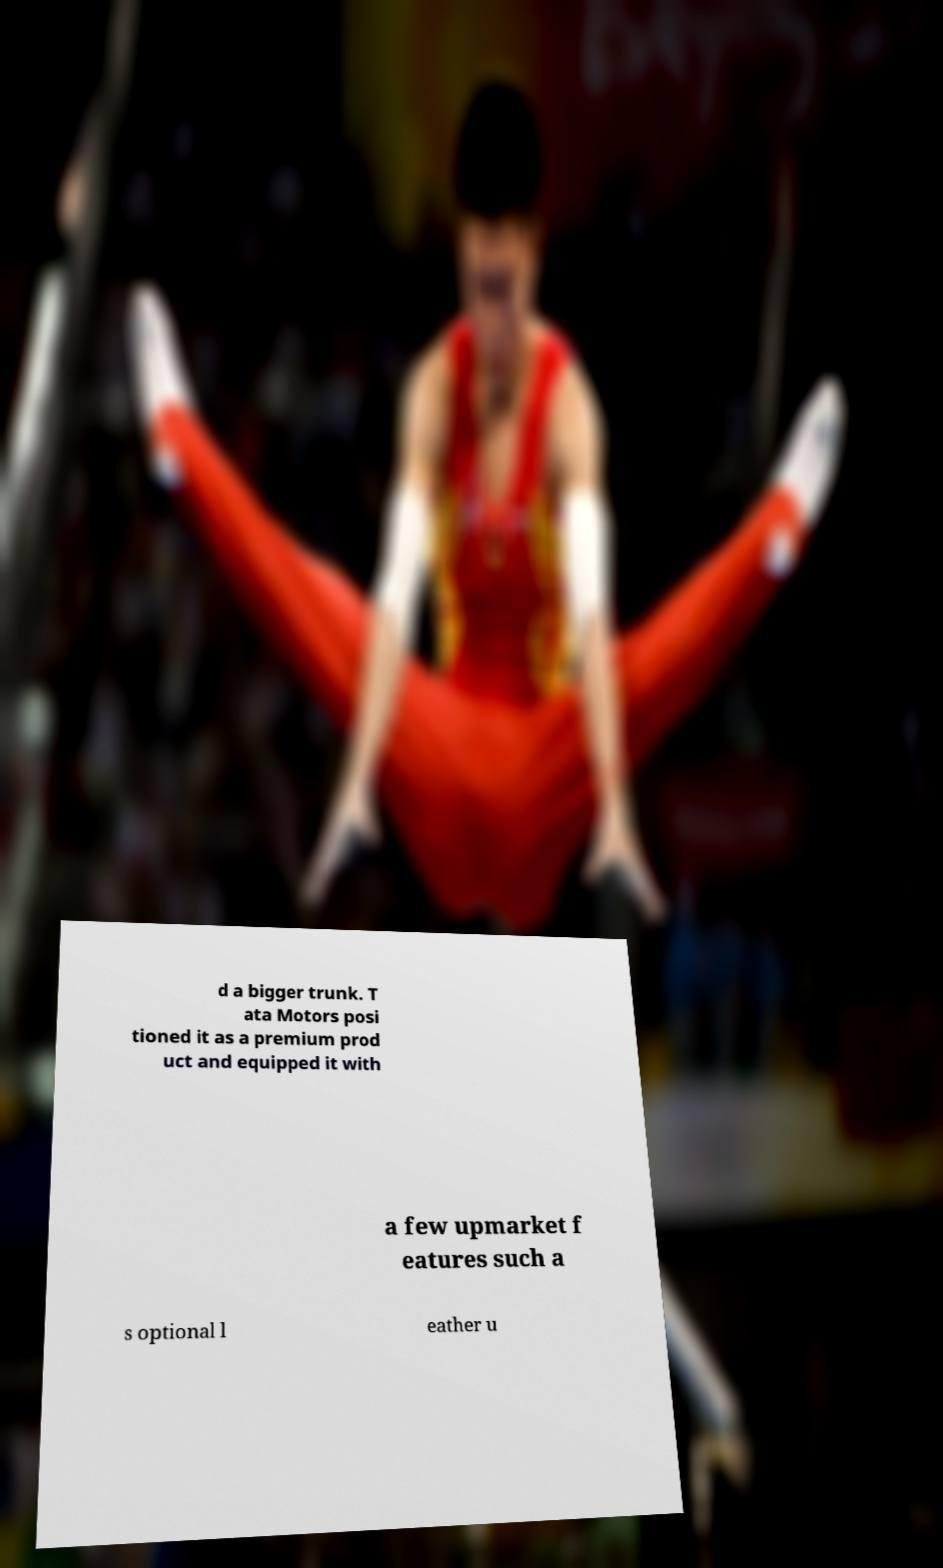I need the written content from this picture converted into text. Can you do that? d a bigger trunk. T ata Motors posi tioned it as a premium prod uct and equipped it with a few upmarket f eatures such a s optional l eather u 